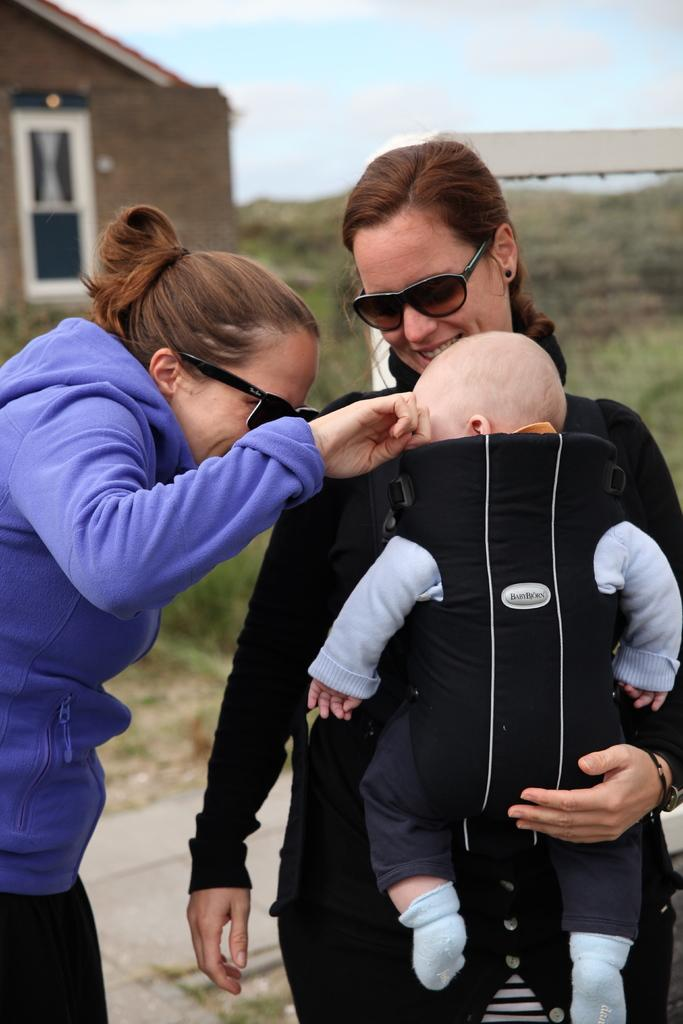Where was the image taken? The image was clicked outside. How many people are in the image? There are three persons in the image. Can you describe the gender of the people in the image? Two of the persons are women, and one is a kid. What can be seen at the top of the image? There are houses at the top of the image. What is present in the middle of the image? There are bushes in the middle of the image. What is visible at the top of the image? The sky is visible at the top of the image. How many cats are sleeping on the calculator in the image? There are no cats or calculators present in the image. 